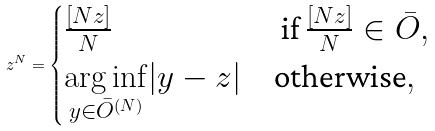Convert formula to latex. <formula><loc_0><loc_0><loc_500><loc_500>z ^ { N } = \begin{cases} \frac { [ N z ] } { N } & \text { if } \frac { [ N z ] } { N } \in \bar { O } , \\ \underset { y \in \bar { O } ^ { ( N ) } } { \arg \inf } | y - z | & \text {otherwise} , \end{cases}</formula> 